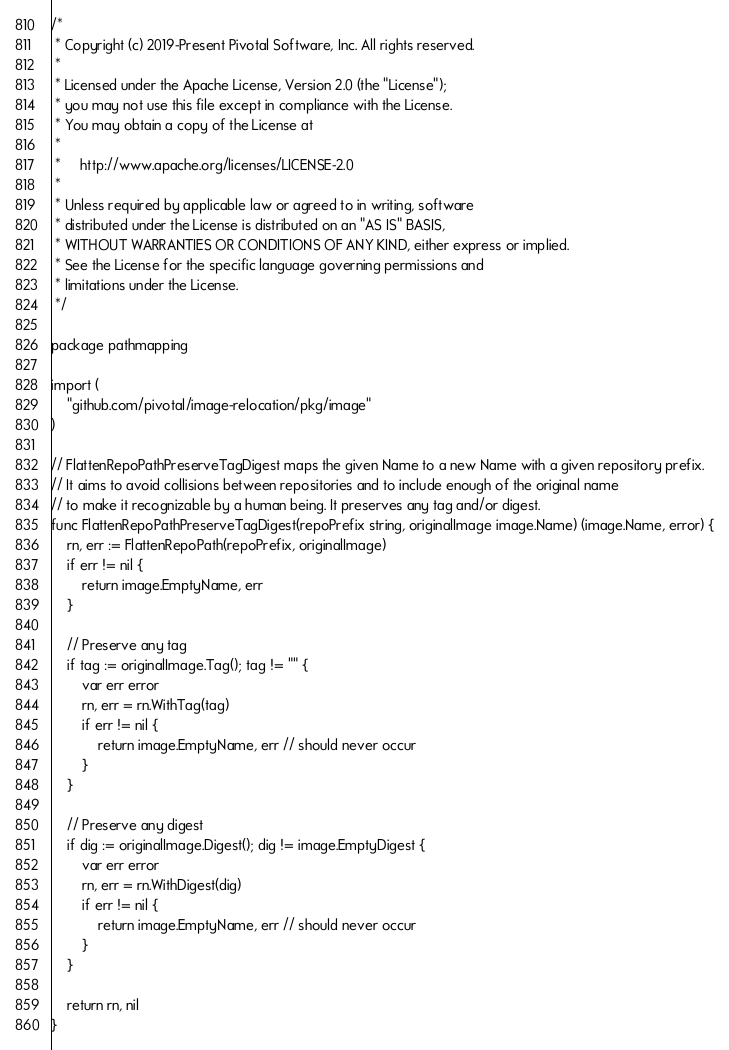Convert code to text. <code><loc_0><loc_0><loc_500><loc_500><_Go_>/*
 * Copyright (c) 2019-Present Pivotal Software, Inc. All rights reserved.
 *
 * Licensed under the Apache License, Version 2.0 (the "License");
 * you may not use this file except in compliance with the License.
 * You may obtain a copy of the License at
 *
 *     http://www.apache.org/licenses/LICENSE-2.0
 *
 * Unless required by applicable law or agreed to in writing, software
 * distributed under the License is distributed on an "AS IS" BASIS,
 * WITHOUT WARRANTIES OR CONDITIONS OF ANY KIND, either express or implied.
 * See the License for the specific language governing permissions and
 * limitations under the License.
 */

package pathmapping

import (
	"github.com/pivotal/image-relocation/pkg/image"
)

// FlattenRepoPathPreserveTagDigest maps the given Name to a new Name with a given repository prefix.
// It aims to avoid collisions between repositories and to include enough of the original name
// to make it recognizable by a human being. It preserves any tag and/or digest.
func FlattenRepoPathPreserveTagDigest(repoPrefix string, originalImage image.Name) (image.Name, error) {
	rn, err := FlattenRepoPath(repoPrefix, originalImage)
	if err != nil {
		return image.EmptyName, err
	}

	// Preserve any tag
	if tag := originalImage.Tag(); tag != "" {
		var err error
		rn, err = rn.WithTag(tag)
		if err != nil {
			return image.EmptyName, err // should never occur
		}
	}

	// Preserve any digest
	if dig := originalImage.Digest(); dig != image.EmptyDigest {
		var err error
		rn, err = rn.WithDigest(dig)
		if err != nil {
			return image.EmptyName, err // should never occur
		}
	}

	return rn, nil
}
</code> 